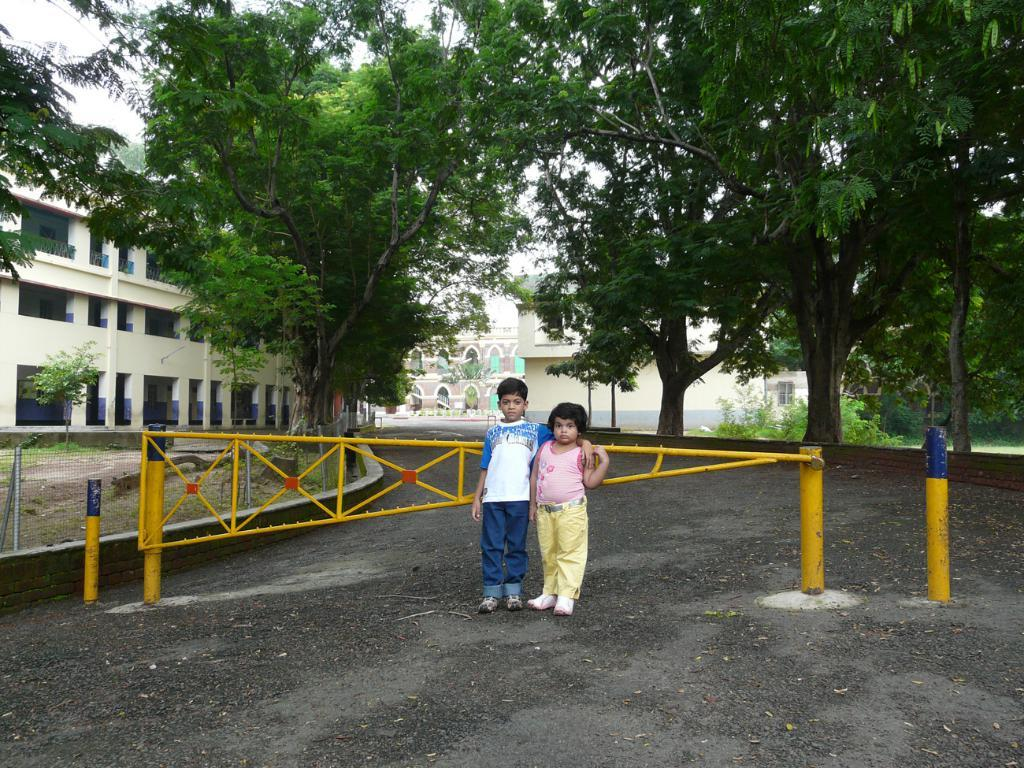How many children are in the image? There are two children in the image. What can be observed about the children's clothing? The children are wearing different color dresses. Where are the children standing in the image? The children are standing on the road. What is near the children in the image? There is a yellow color gate near the children. What can be seen in the background of the image? There are trees, buildings, a fencing, and the sky visible in the background of the image. What type of shop can be seen in the image? There is no shop present in the image. Who is the friend of the children in the image? The image does not show any friends of the children; it only features the two children. 